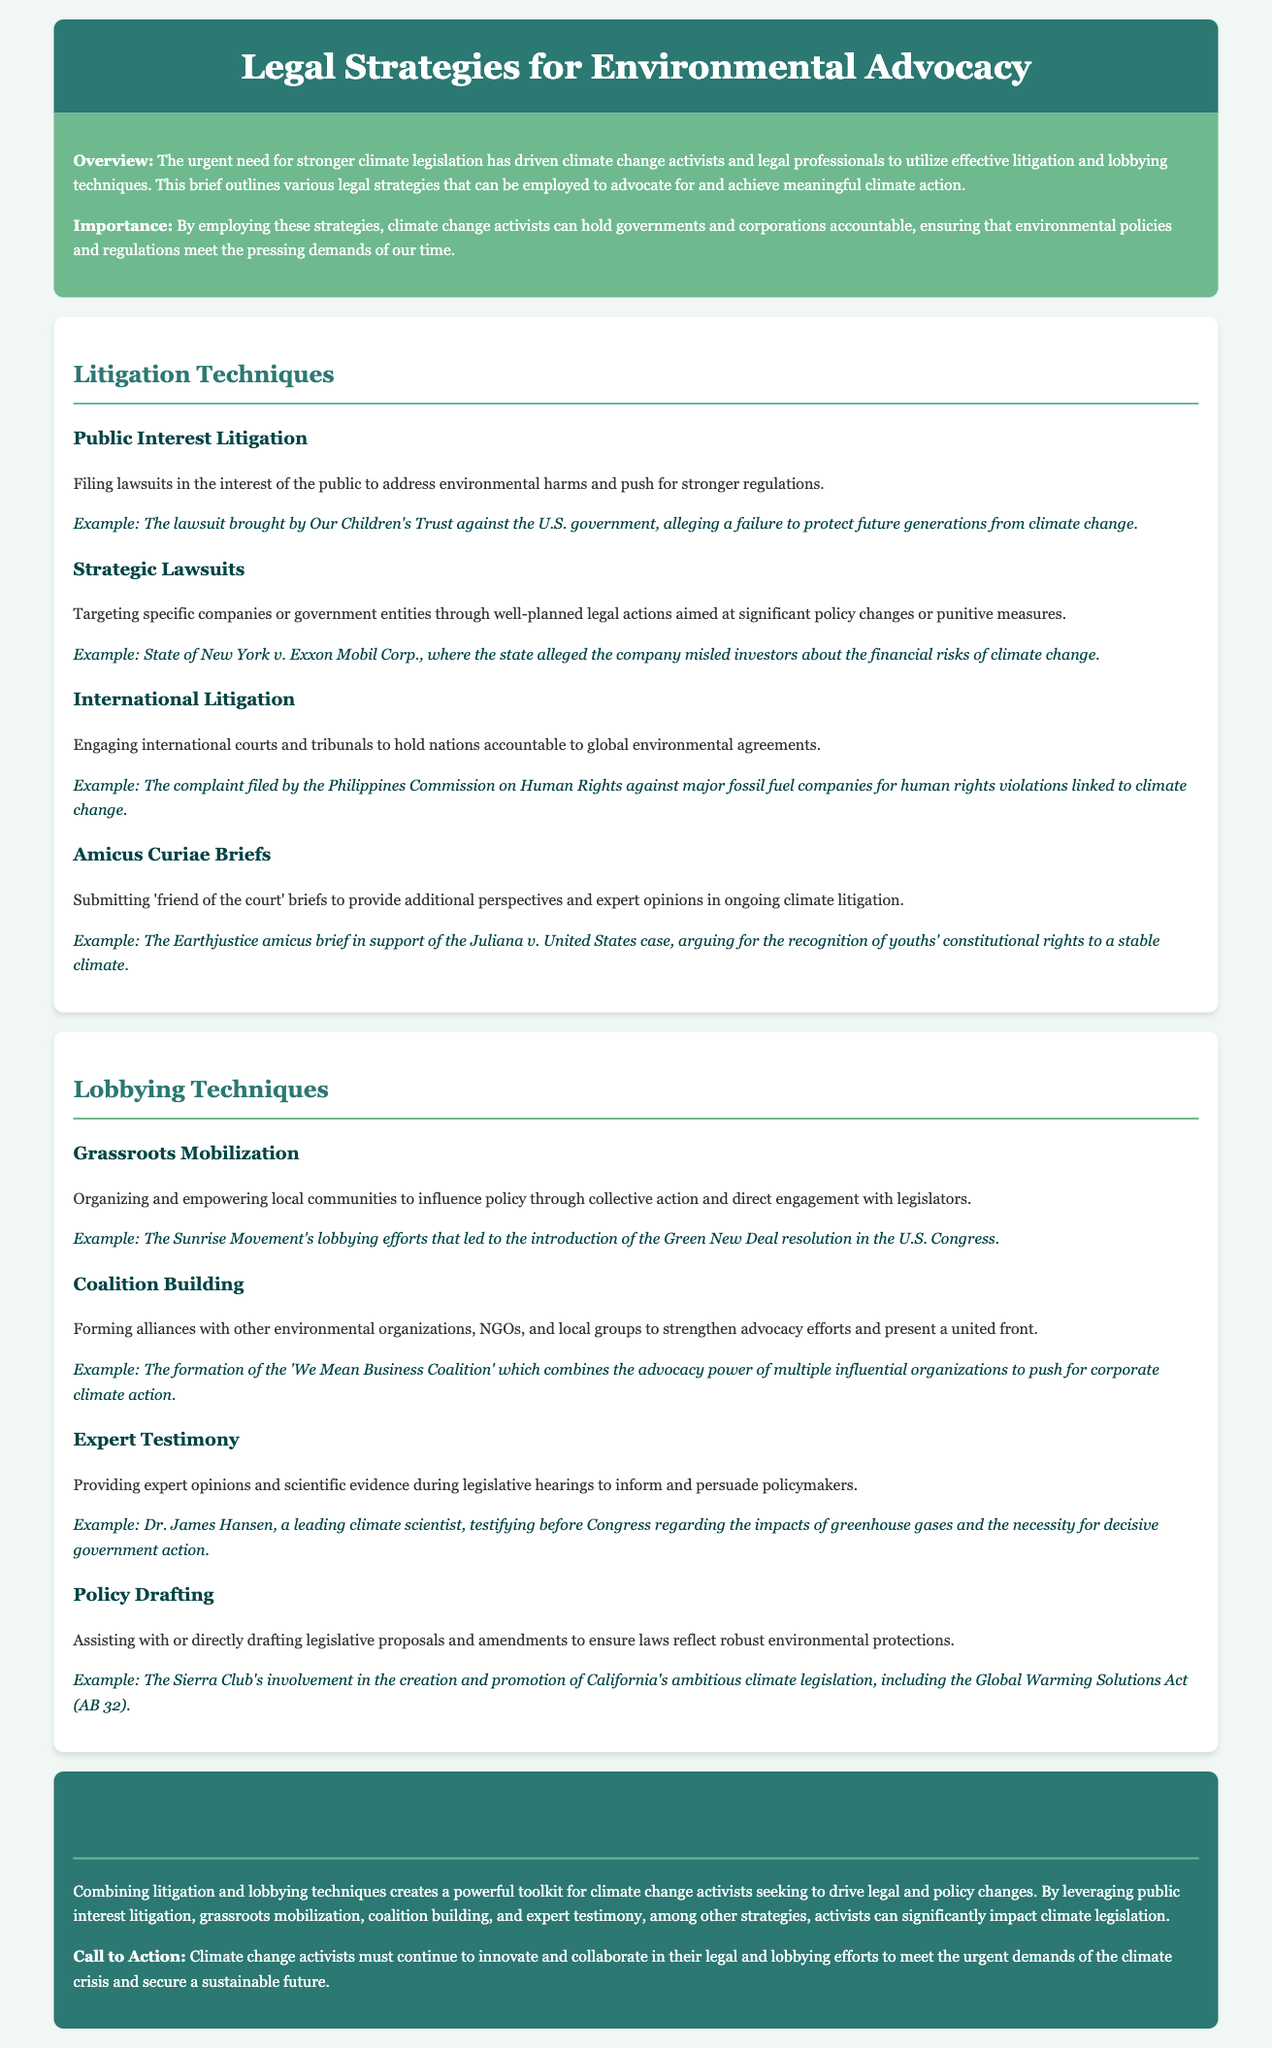what is the main focus of the legal brief? The main focus of the legal brief is to outline legal strategies for environmental advocacy through litigation and lobbying techniques.
Answer: legal strategies for environmental advocacy who filed the lawsuit against the U.S. government for climate change? The lawsuit was brought by Our Children's Trust against the U.S. government.
Answer: Our Children's Trust what is the example given for Strategic Lawsuits? The example provided is the case of State of New York v. Exxon Mobil Corp.
Answer: State of New York v. Exxon Mobil Corp which coalition is mentioned as an example of coalition building? The example of coalition building mentioned is the 'We Mean Business Coalition.'
Answer: 'We Mean Business Coalition' what does expert testimony aim to influence? Expert testimony aims to influence policymakers during legislative hearings.
Answer: policymakers how does the document categorize its content? The document categorizes its content into Litigation Techniques and Lobbying Techniques.
Answer: Litigation Techniques and Lobbying Techniques what is the purpose of amicus curiae briefs? The purpose of amicus curiae briefs is to provide additional perspectives and expert opinions in ongoing climate litigation.
Answer: additional perspectives and expert opinions who testified before Congress regarding greenhouse gases? Dr. James Hansen testified before Congress regarding greenhouse gases.
Answer: Dr. James Hansen what is the call to action for activists at the end of the brief? The call to action for activists is to continue to innovate and collaborate in their legal and lobbying efforts.
Answer: continue to innovate and collaborate 